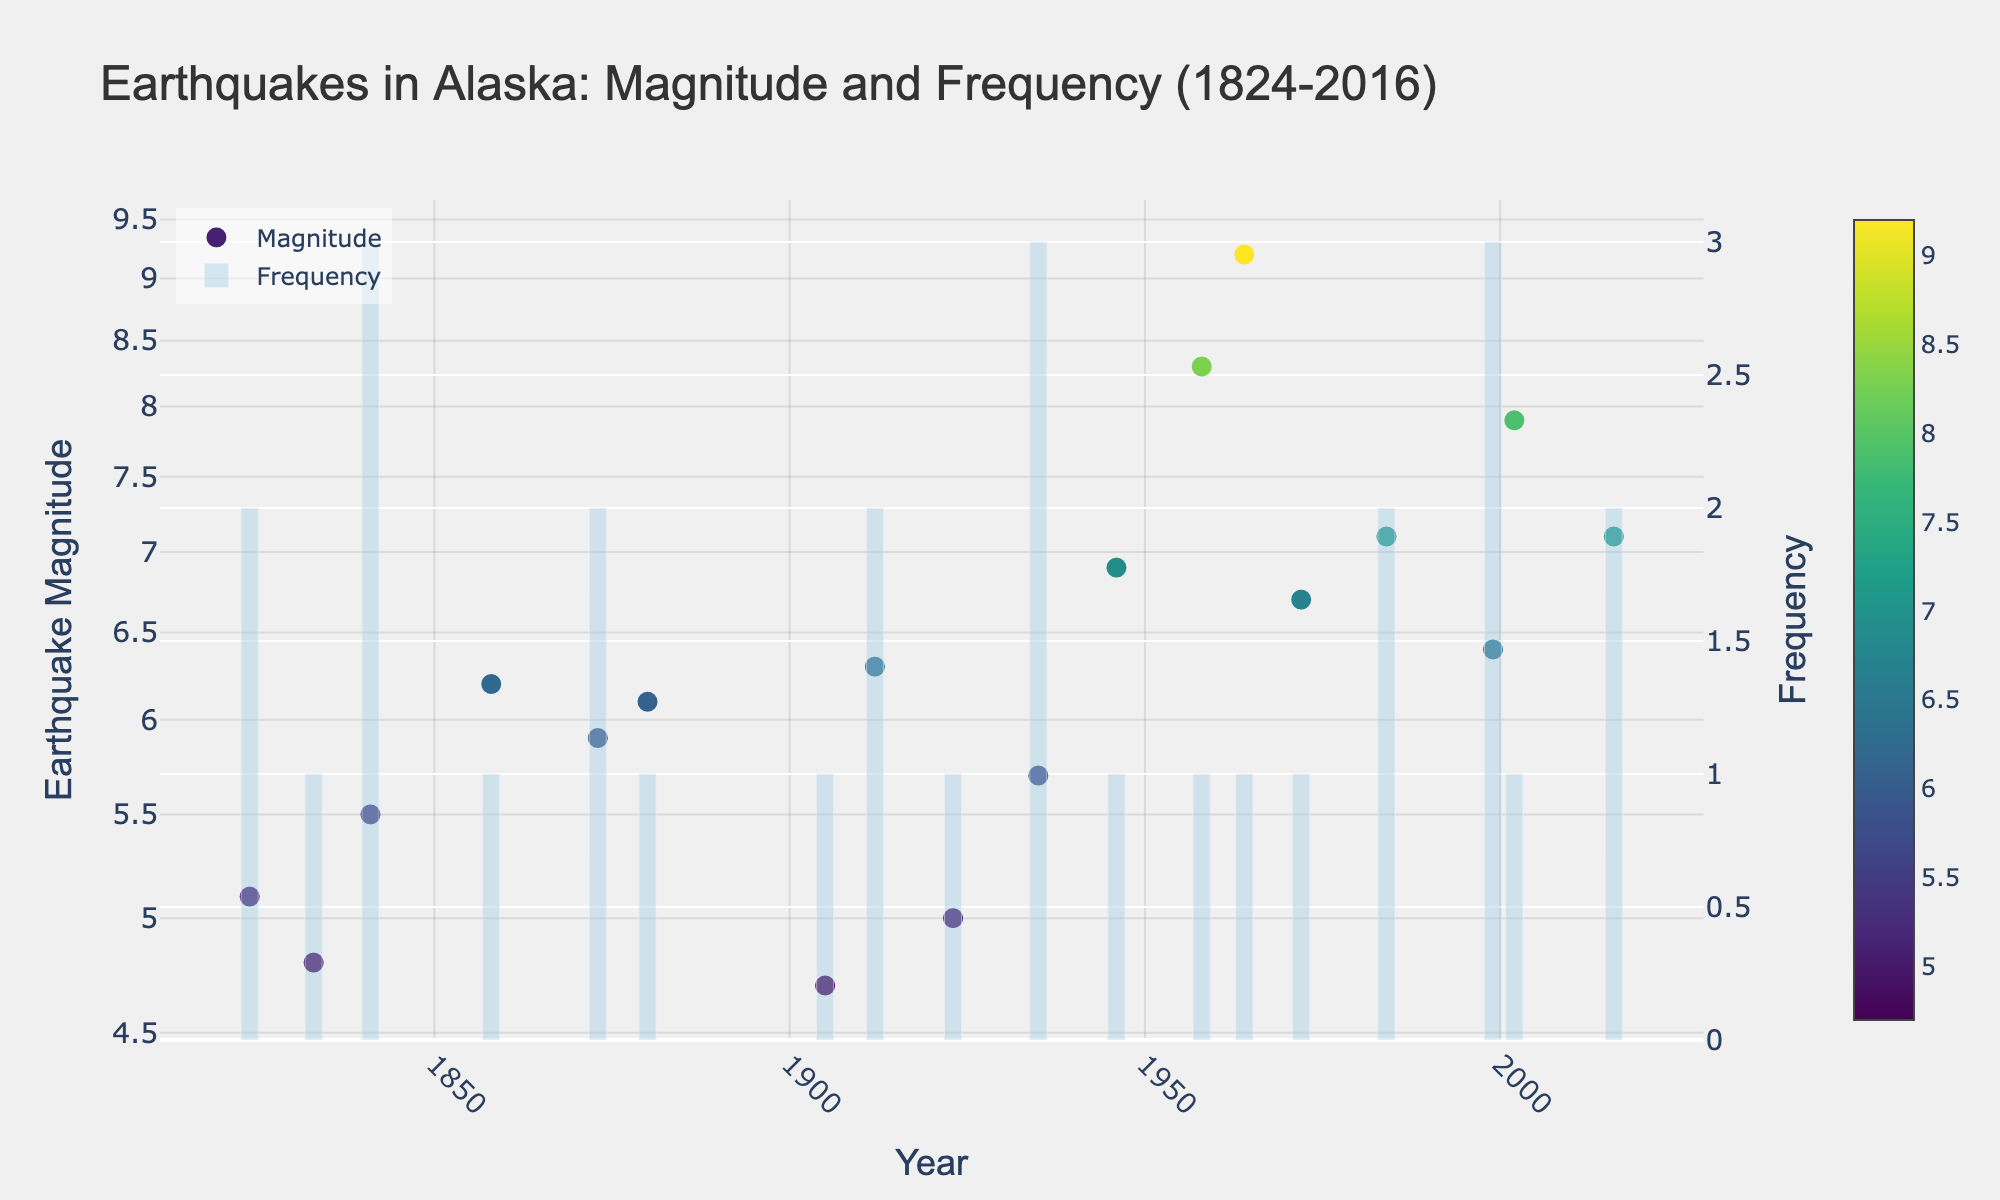What is the title of the figure? The title is usually found at the top of the figure and summarizes what the plot is about. In this case, it is "Earthquakes in Alaska: Magnitude and Frequency (1824-2016)."
Answer: Earthquakes in Alaska: Magnitude and Frequency (1824-2016) What does the x-axis represent? The x-axis typically shows the independent variable. Here, it is labeled "Year," which indicates it represents the years from 1824 to 2016.
Answer: Year What does the y-axis on the right represent? The y-axis on the right side of the plot represents the frequency of earthquakes, as indicated by the label "Frequency."
Answer: Frequency In which year did Anchorage experience the highest earthquake magnitude? By looking at the scatter plot points, we can identify the year with the highest magnitude at Anchorage. Anchorage's highest magnitude is seen in 1964 with a magnitude of 9.2.
Answer: 1964 Was there ever a year with a frequency of 3 earthquakes? By inspecting the heights of the bar chart, we see that there are years, such as 1841, 1935, and 1999, where the frequency of earthquakes reached 3.
Answer: Yes What is the magnitude range of the earthquakes shown in the plot? By inspecting the y-axis on the left and the spread of the points, we see the magnitudes range from around 4.7 to 9.2.
Answer: 4.7 to 9.2 Which earthquake had a higher magnitude: 1984 in Kodiak or 2002 in Denali? By comparing the points for Kodiak in 1984 and Denali in 2002, we see that Denali in 2002 had a higher magnitude of 7.9 compared to Kodiak in 1984 with a magnitude of 7.1.
Answer: 2002 in Denali How many earthquakes with a magnitude higher than 7.0 are there in total? Observing the scatter plot points that are above the 7.0 magnitude line on the y-axis, we count three points: Sitka in 1958, Denali in 2002, and Kodiak in 1984.
Answer: 3 Which year had the highest frequency of earthquakes? By finding the tallest bar in the bar chart, we see that the years 1841, 1935, and 1999 share the highest frequency, each having a frequency of 3.
Answer: 1841, 1935, 1999 What is the difference in magnitude between the 1964 Anchorage earthquake and the 1958 Sitka earthquake? The magnitude of the 1964 Anchorage earthquake is 9.2, and for the 1958 Sitka earthquake, it is 8.3. The difference is calculated as 9.2 - 8.3.
Answer: 0.9 